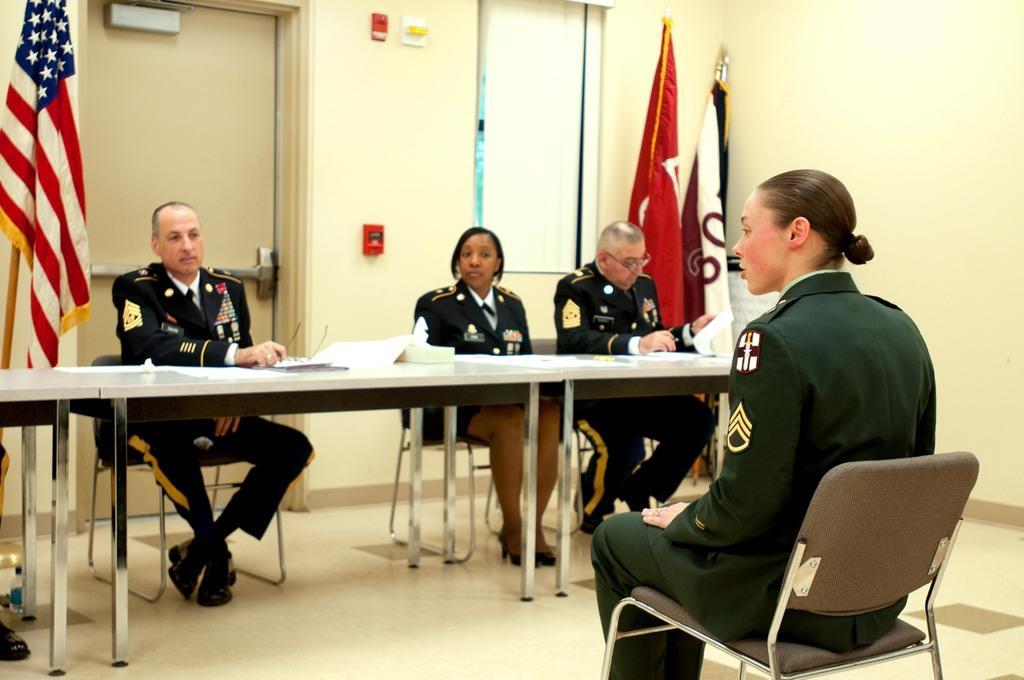Could you give a brief overview of what you see in this image? In this image,There is a big table which is in white color,there are some people sitting on the chairs,In front of the table there a woman sitting on the black color chair,In the background there are some flags and there is a door which is in brown color and there is a wall which is in white color. 